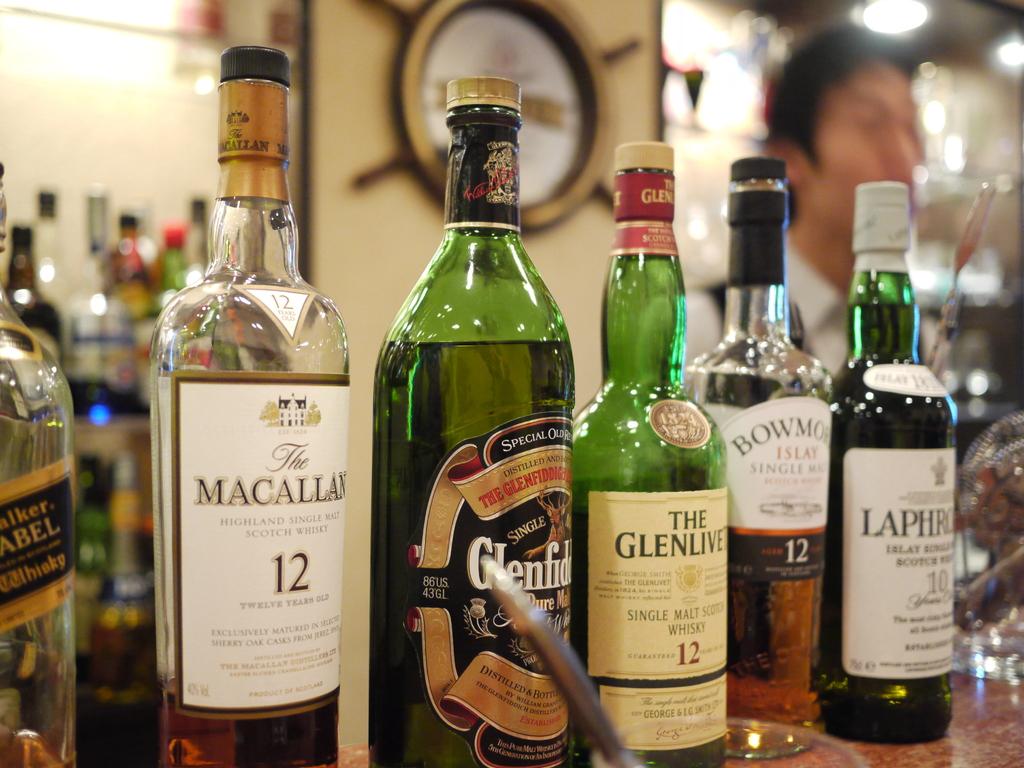What brand is on the left hand side bottle?
Offer a terse response. Macallan. What brand is on the bottle on the right side?
Ensure brevity in your answer.  Unanswerable. 